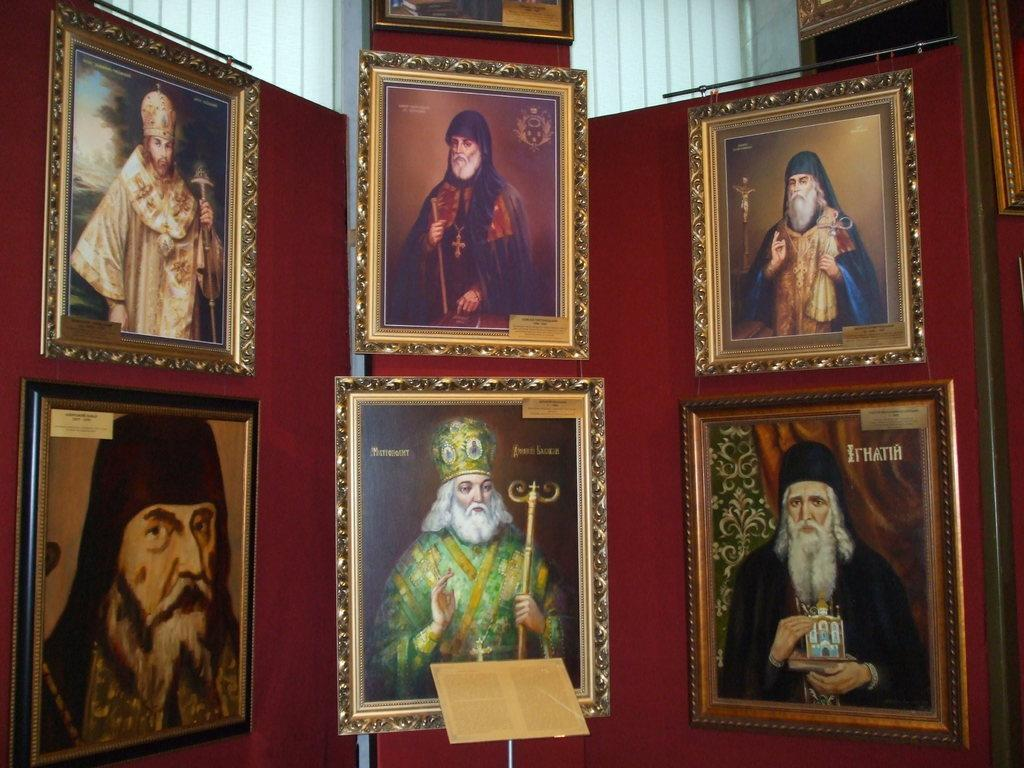What is hanging on the wall in the image? There are photo frames on a wall in the image. What can be seen inside the photo frames? The photo frames contain pictures of people. What is located at the bottom of the image? There is a speaker stand at the bottom of the image. How many horses are pulling the cart in the image? There is no cart or horses present in the image. What type of rake is being used to clean the area in the image? There is no rake visible in the image. 